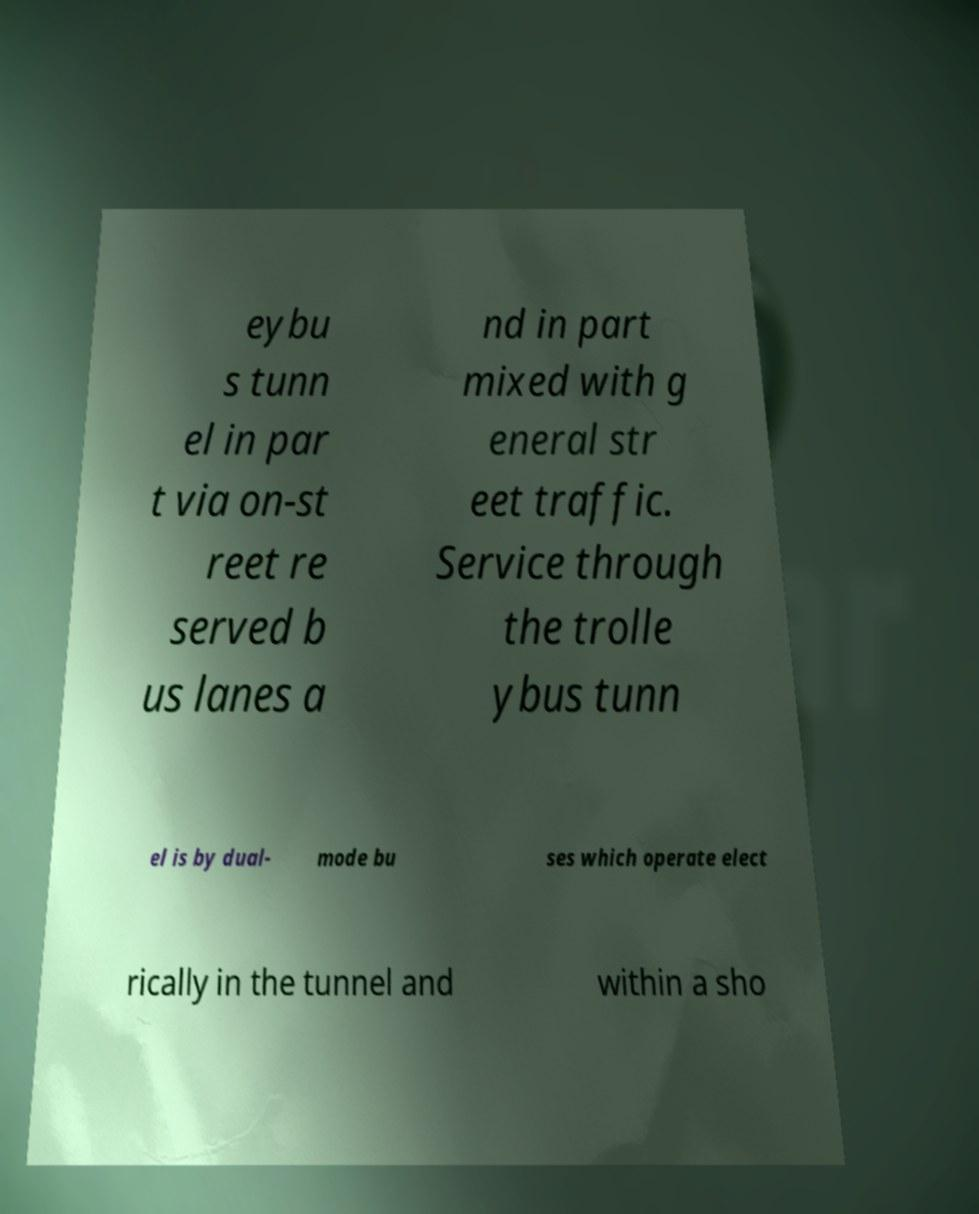There's text embedded in this image that I need extracted. Can you transcribe it verbatim? eybu s tunn el in par t via on-st reet re served b us lanes a nd in part mixed with g eneral str eet traffic. Service through the trolle ybus tunn el is by dual- mode bu ses which operate elect rically in the tunnel and within a sho 